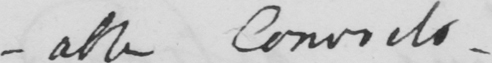Transcribe the text shown in this historical manuscript line. -able Convicts _ 